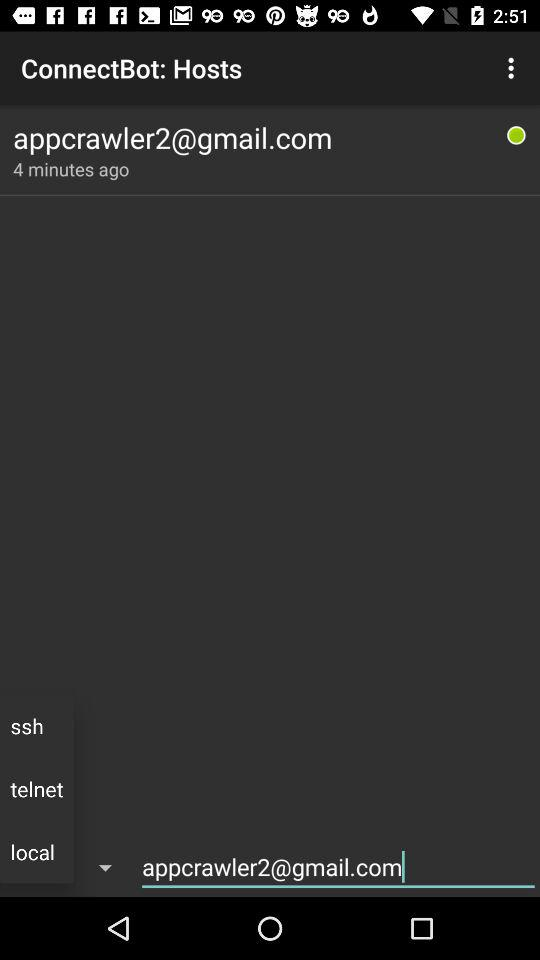What is the name of the application? The name of the application is "ConnectBot". 